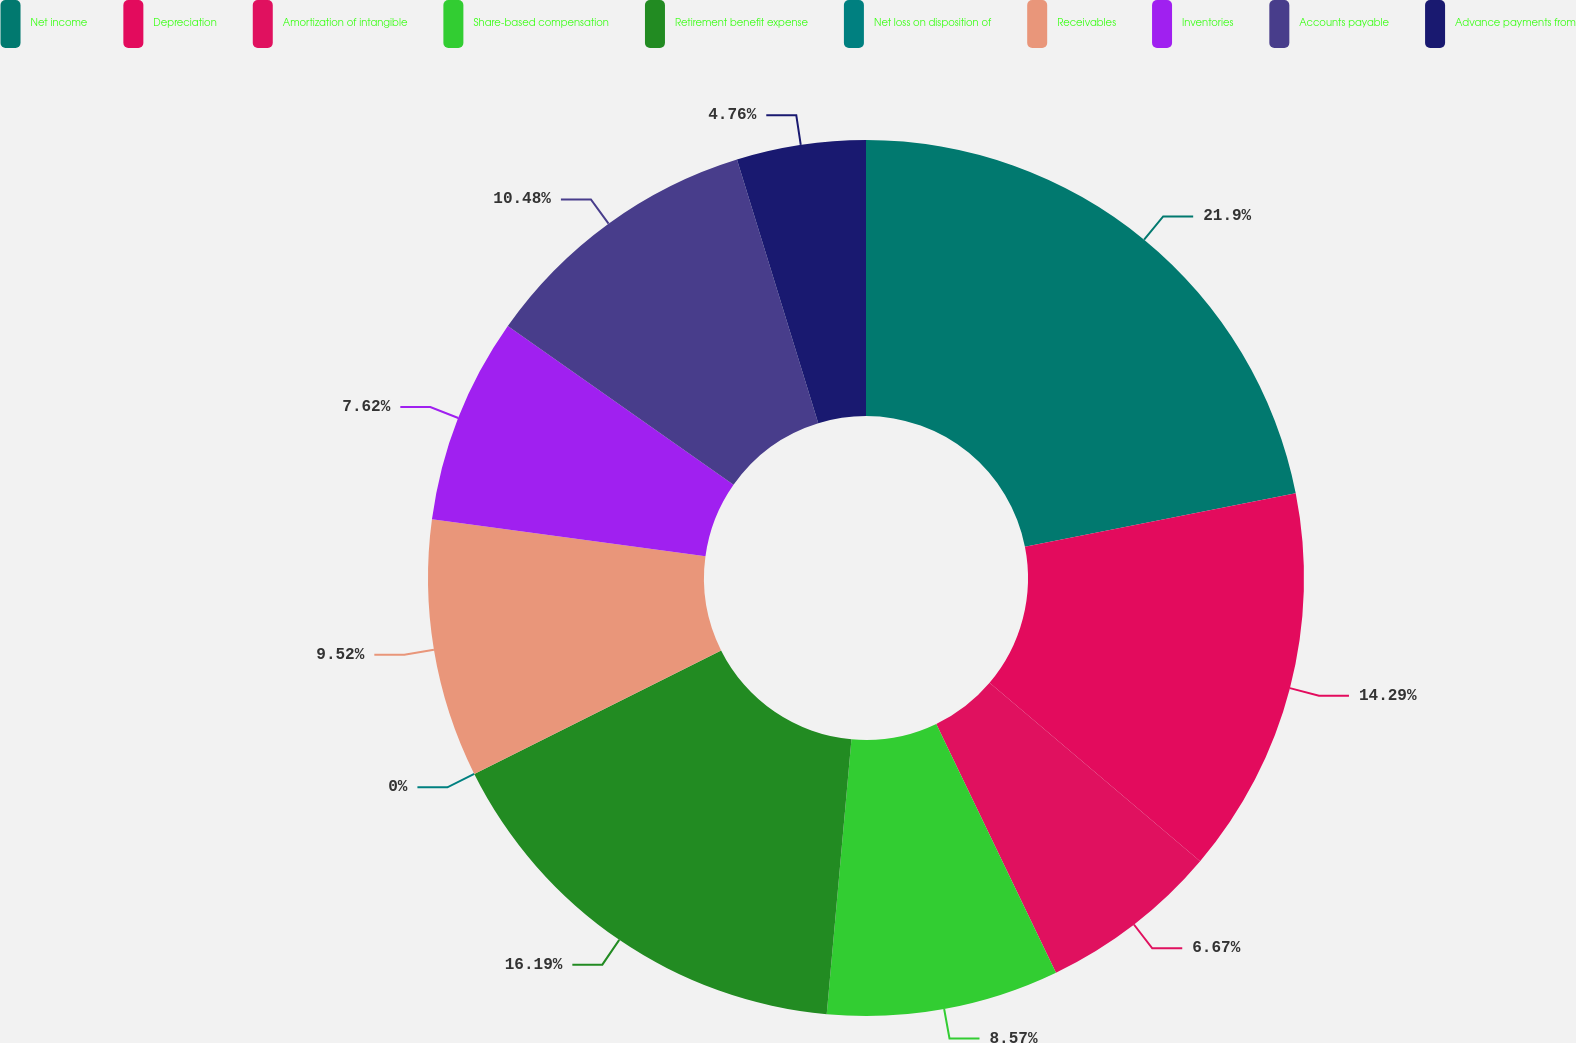Convert chart. <chart><loc_0><loc_0><loc_500><loc_500><pie_chart><fcel>Net income<fcel>Depreciation<fcel>Amortization of intangible<fcel>Share-based compensation<fcel>Retirement benefit expense<fcel>Net loss on disposition of<fcel>Receivables<fcel>Inventories<fcel>Accounts payable<fcel>Advance payments from<nl><fcel>21.9%<fcel>14.29%<fcel>6.67%<fcel>8.57%<fcel>16.19%<fcel>0.0%<fcel>9.52%<fcel>7.62%<fcel>10.48%<fcel>4.76%<nl></chart> 